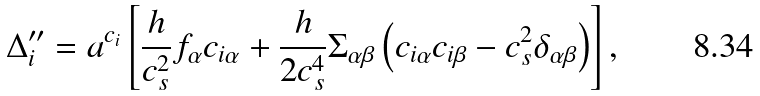Convert formula to latex. <formula><loc_0><loc_0><loc_500><loc_500>\Delta _ { i } ^ { \prime \prime } = a ^ { c _ { i } } \left [ \frac { h } { c _ { s } ^ { 2 } } f _ { \alpha } c _ { i \alpha } + \frac { h } { 2 c _ { s } ^ { 4 } } \Sigma _ { \alpha \beta } \left ( c _ { i \alpha } c _ { i \beta } - c _ { s } ^ { 2 } \delta _ { \alpha \beta } \right ) \right ] ,</formula> 